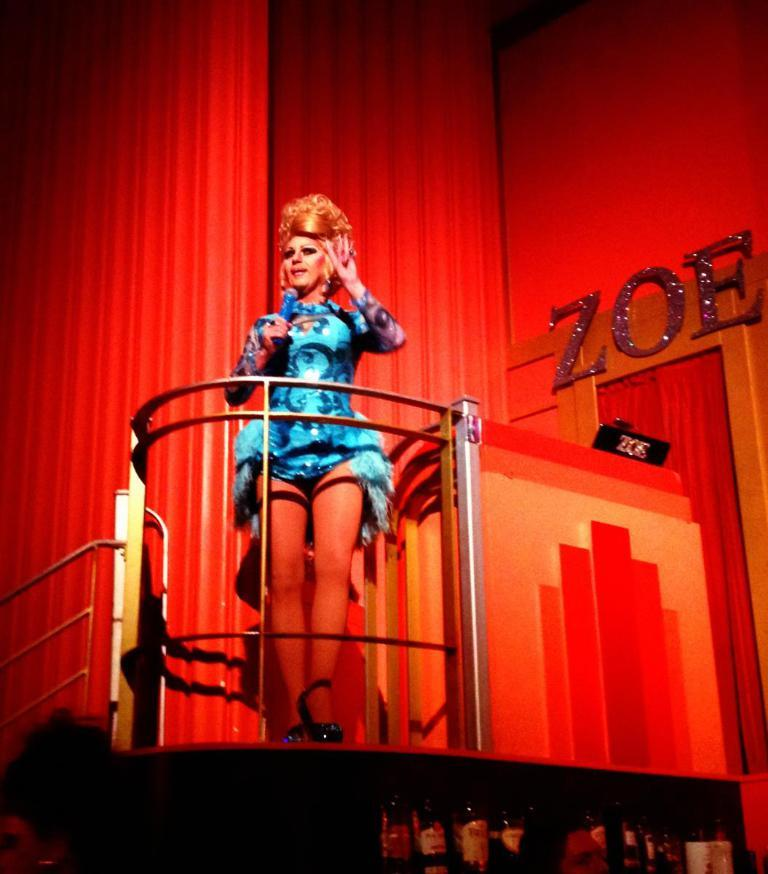What is the woman in the image doing? The woman is standing in the image and holding a microphone in her hands. What type of footwear is the woman wearing? The woman is wearing sandals. What can be seen behind the woman in the image? There is a fence, text, and a wall visible in the image. What is the woman's theory about the stitch in the image? There is no stitch present in the image, so it is not possible to discuss a theory about it. 